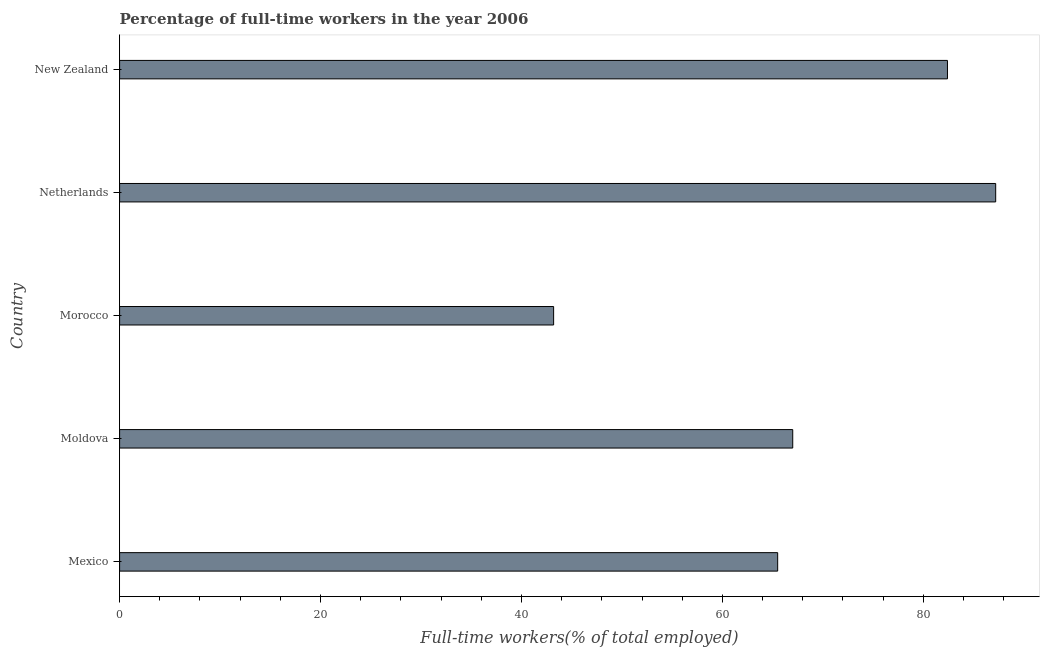Does the graph contain any zero values?
Keep it short and to the point. No. Does the graph contain grids?
Give a very brief answer. No. What is the title of the graph?
Ensure brevity in your answer.  Percentage of full-time workers in the year 2006. What is the label or title of the X-axis?
Keep it short and to the point. Full-time workers(% of total employed). What is the label or title of the Y-axis?
Offer a very short reply. Country. What is the percentage of full-time workers in Morocco?
Make the answer very short. 43.2. Across all countries, what is the maximum percentage of full-time workers?
Provide a succinct answer. 87.2. Across all countries, what is the minimum percentage of full-time workers?
Offer a terse response. 43.2. In which country was the percentage of full-time workers minimum?
Provide a succinct answer. Morocco. What is the sum of the percentage of full-time workers?
Offer a terse response. 345.3. What is the difference between the percentage of full-time workers in Netherlands and New Zealand?
Make the answer very short. 4.8. What is the average percentage of full-time workers per country?
Your response must be concise. 69.06. What is the median percentage of full-time workers?
Ensure brevity in your answer.  67. What is the ratio of the percentage of full-time workers in Morocco to that in New Zealand?
Keep it short and to the point. 0.52. Is the percentage of full-time workers in Moldova less than that in New Zealand?
Make the answer very short. Yes. What is the difference between the highest and the second highest percentage of full-time workers?
Give a very brief answer. 4.8. In how many countries, is the percentage of full-time workers greater than the average percentage of full-time workers taken over all countries?
Your answer should be very brief. 2. Are all the bars in the graph horizontal?
Your response must be concise. Yes. What is the difference between two consecutive major ticks on the X-axis?
Make the answer very short. 20. Are the values on the major ticks of X-axis written in scientific E-notation?
Give a very brief answer. No. What is the Full-time workers(% of total employed) in Mexico?
Make the answer very short. 65.5. What is the Full-time workers(% of total employed) of Moldova?
Your response must be concise. 67. What is the Full-time workers(% of total employed) in Morocco?
Ensure brevity in your answer.  43.2. What is the Full-time workers(% of total employed) in Netherlands?
Your answer should be compact. 87.2. What is the Full-time workers(% of total employed) of New Zealand?
Your answer should be very brief. 82.4. What is the difference between the Full-time workers(% of total employed) in Mexico and Morocco?
Make the answer very short. 22.3. What is the difference between the Full-time workers(% of total employed) in Mexico and Netherlands?
Provide a succinct answer. -21.7. What is the difference between the Full-time workers(% of total employed) in Mexico and New Zealand?
Keep it short and to the point. -16.9. What is the difference between the Full-time workers(% of total employed) in Moldova and Morocco?
Your answer should be compact. 23.8. What is the difference between the Full-time workers(% of total employed) in Moldova and Netherlands?
Ensure brevity in your answer.  -20.2. What is the difference between the Full-time workers(% of total employed) in Moldova and New Zealand?
Keep it short and to the point. -15.4. What is the difference between the Full-time workers(% of total employed) in Morocco and Netherlands?
Provide a short and direct response. -44. What is the difference between the Full-time workers(% of total employed) in Morocco and New Zealand?
Your answer should be compact. -39.2. What is the ratio of the Full-time workers(% of total employed) in Mexico to that in Morocco?
Your answer should be very brief. 1.52. What is the ratio of the Full-time workers(% of total employed) in Mexico to that in Netherlands?
Make the answer very short. 0.75. What is the ratio of the Full-time workers(% of total employed) in Mexico to that in New Zealand?
Keep it short and to the point. 0.8. What is the ratio of the Full-time workers(% of total employed) in Moldova to that in Morocco?
Your response must be concise. 1.55. What is the ratio of the Full-time workers(% of total employed) in Moldova to that in Netherlands?
Keep it short and to the point. 0.77. What is the ratio of the Full-time workers(% of total employed) in Moldova to that in New Zealand?
Your answer should be compact. 0.81. What is the ratio of the Full-time workers(% of total employed) in Morocco to that in Netherlands?
Ensure brevity in your answer.  0.49. What is the ratio of the Full-time workers(% of total employed) in Morocco to that in New Zealand?
Make the answer very short. 0.52. What is the ratio of the Full-time workers(% of total employed) in Netherlands to that in New Zealand?
Make the answer very short. 1.06. 